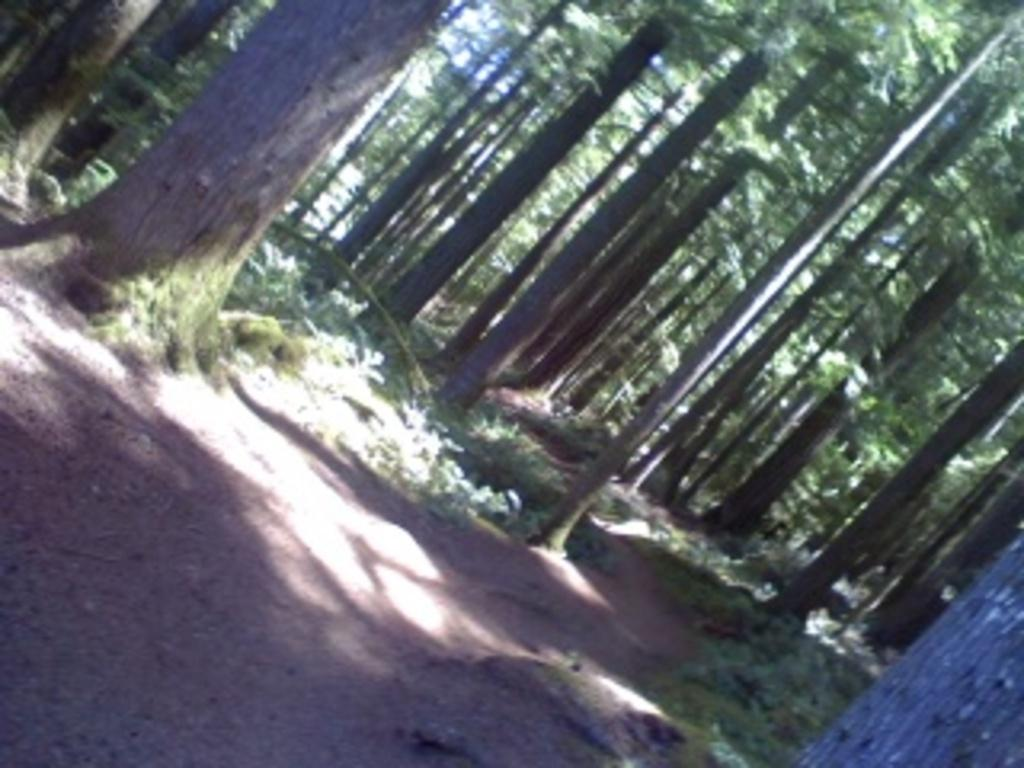What can be observed in the image that indicates the presence of light? There are shadows in the image, which suggest the presence of light. What type of vegetation is visible in the image? There is grass and trees visible in the image. How many loaves of bread can be seen in the image? There are no loaves of bread present in the image. What type of twig is visible in the image? There is no twig visible in the image. 